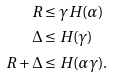Convert formula to latex. <formula><loc_0><loc_0><loc_500><loc_500>R & \leq \gamma H ( \alpha ) \\ \Delta & \leq H ( \gamma ) \\ R + \Delta & \leq H ( \alpha \gamma ) .</formula> 